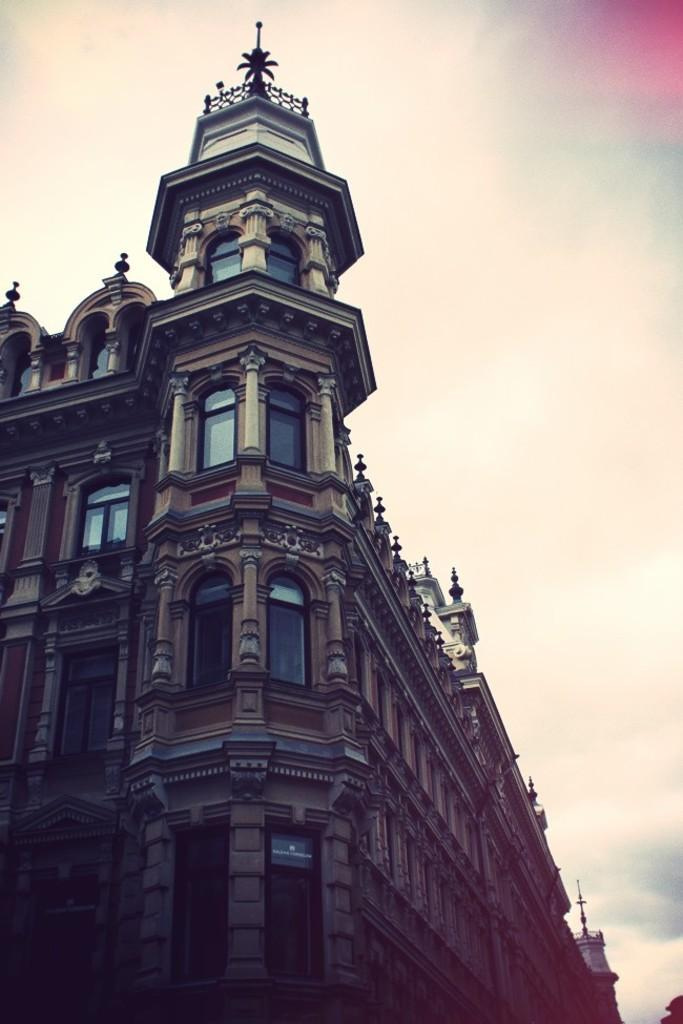What type of structure is visible in the image? There is a building in the image. What feature can be observed on the building? The building has glass windows. What is the condition of the sky in the image? The sky is cloudy in the image. What type of breakfast is being served on the iron table in the image? There is no breakfast or iron table present in the image; it only features a building with glass windows and a cloudy sky. Can you describe the boy playing with the toy car in the image? There is no boy or toy car present in the image. 